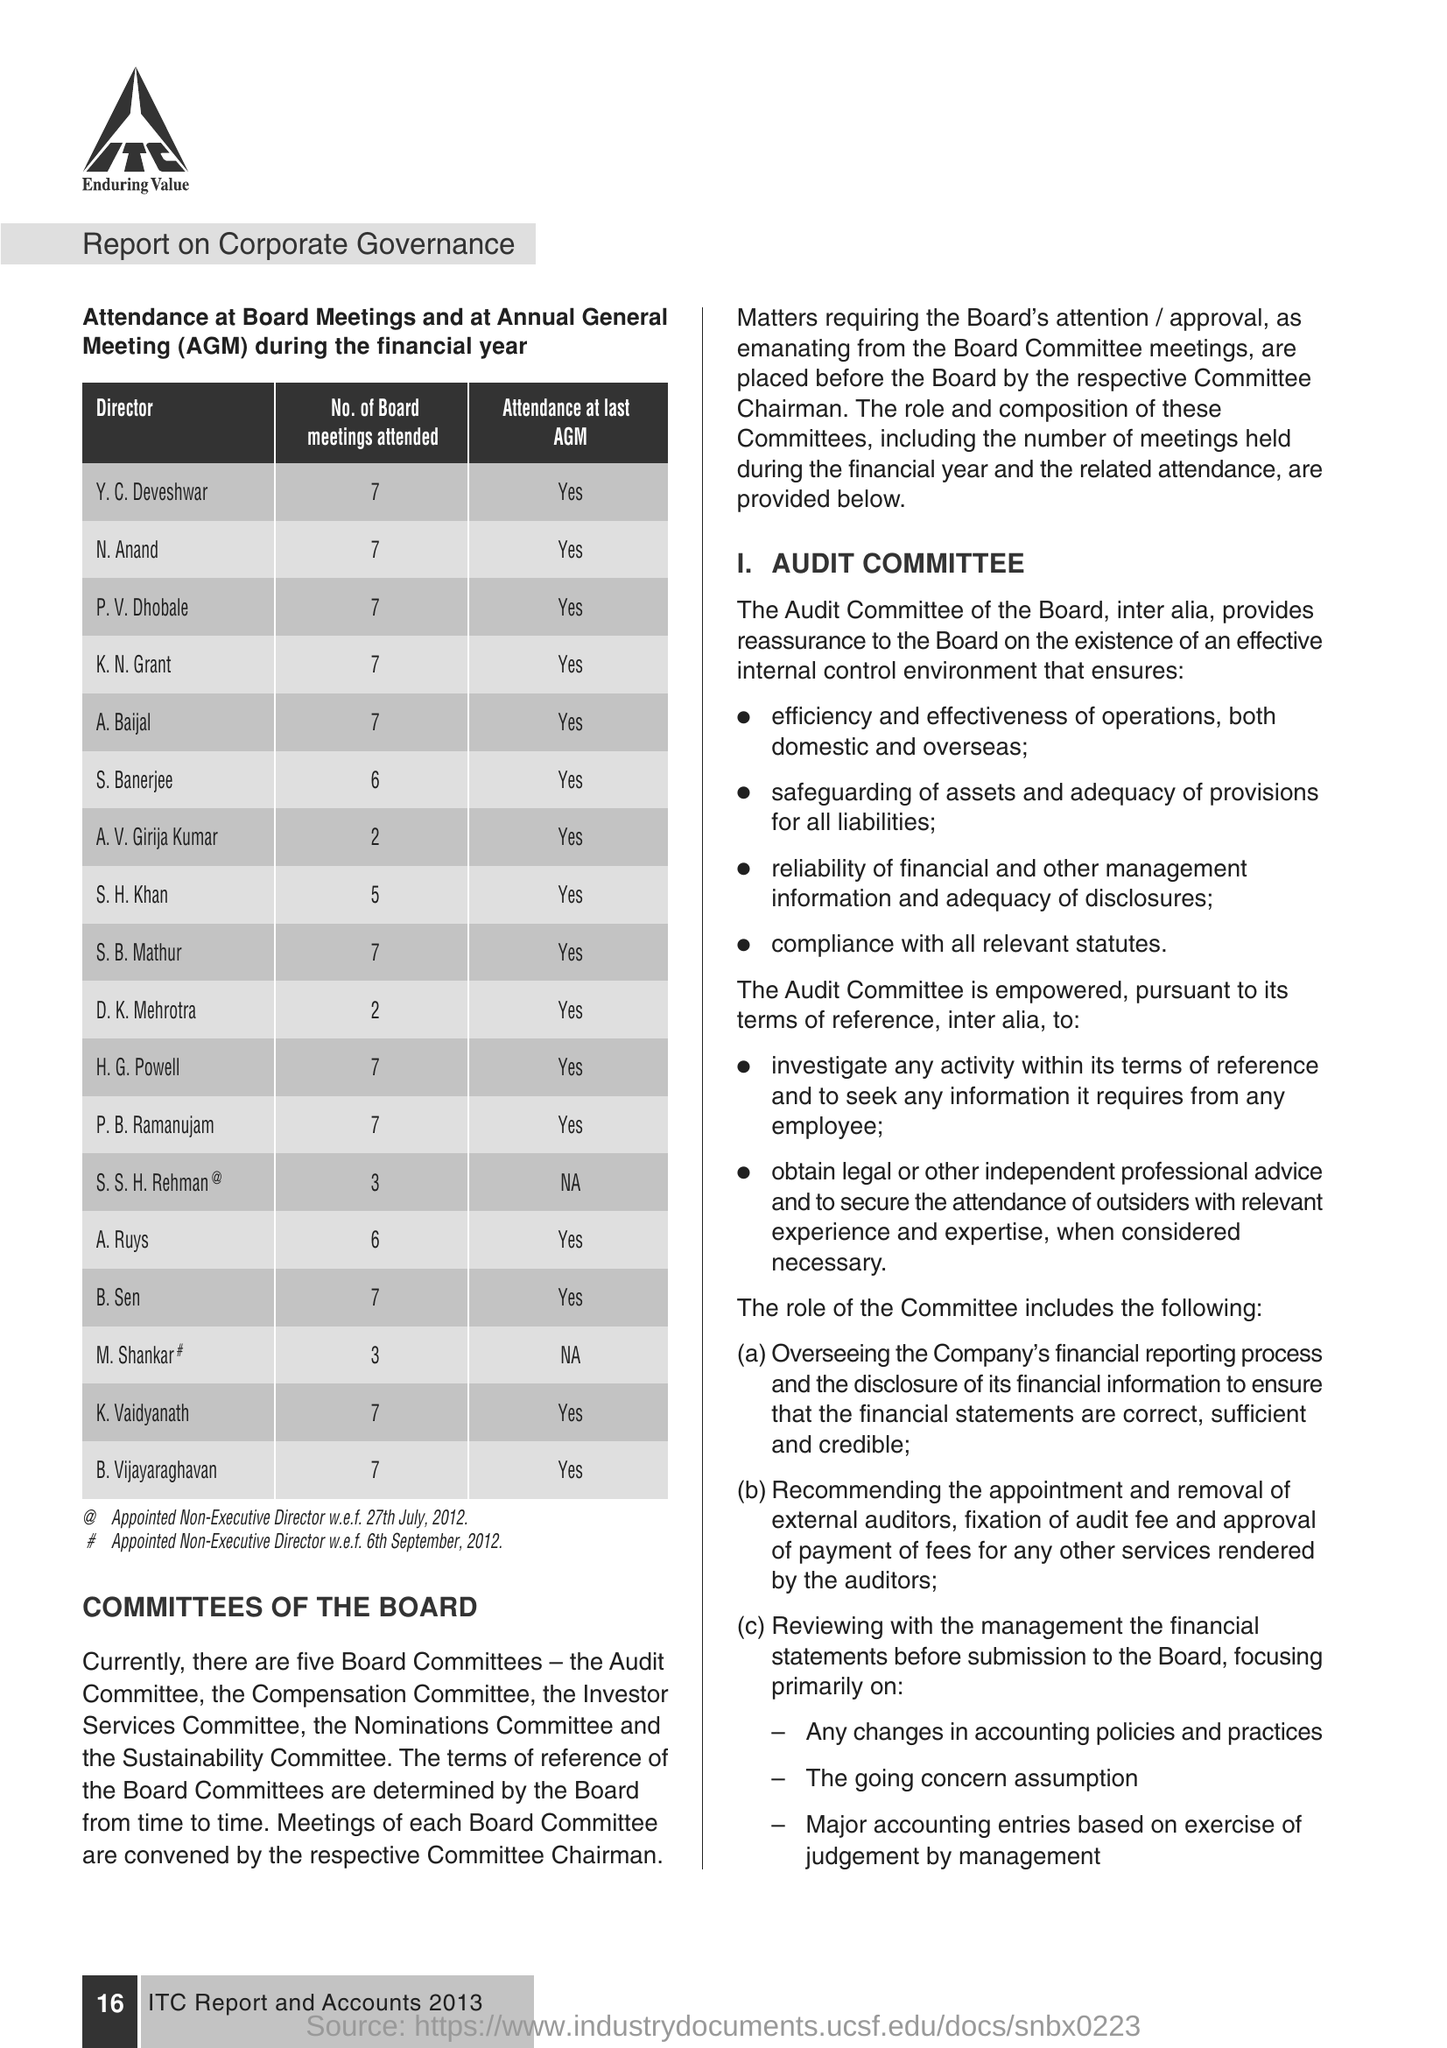What is the Fullform of AGM ?
Ensure brevity in your answer.  Annual General Meeting. How many meetings attend the K.N.Grant ?
Offer a terse response. 7. 